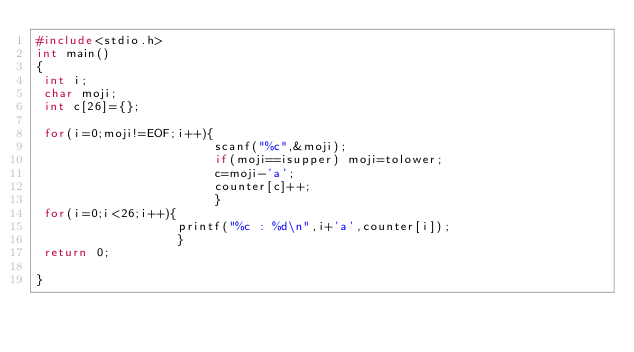<code> <loc_0><loc_0><loc_500><loc_500><_C_>#include<stdio.h>
int main()
{
 int i;
 char moji;
 int c[26]={};

 for(i=0;moji!=EOF;i++){
                        scanf("%c",&moji);
                        if(moji==isupper) moji=tolower;
                        c=moji-'a';
                        counter[c]++;
                        }
 for(i=0;i<26;i++){
                   printf("%c : %d\n",i+'a',counter[i]);
                   }
 return 0;

}

</code> 